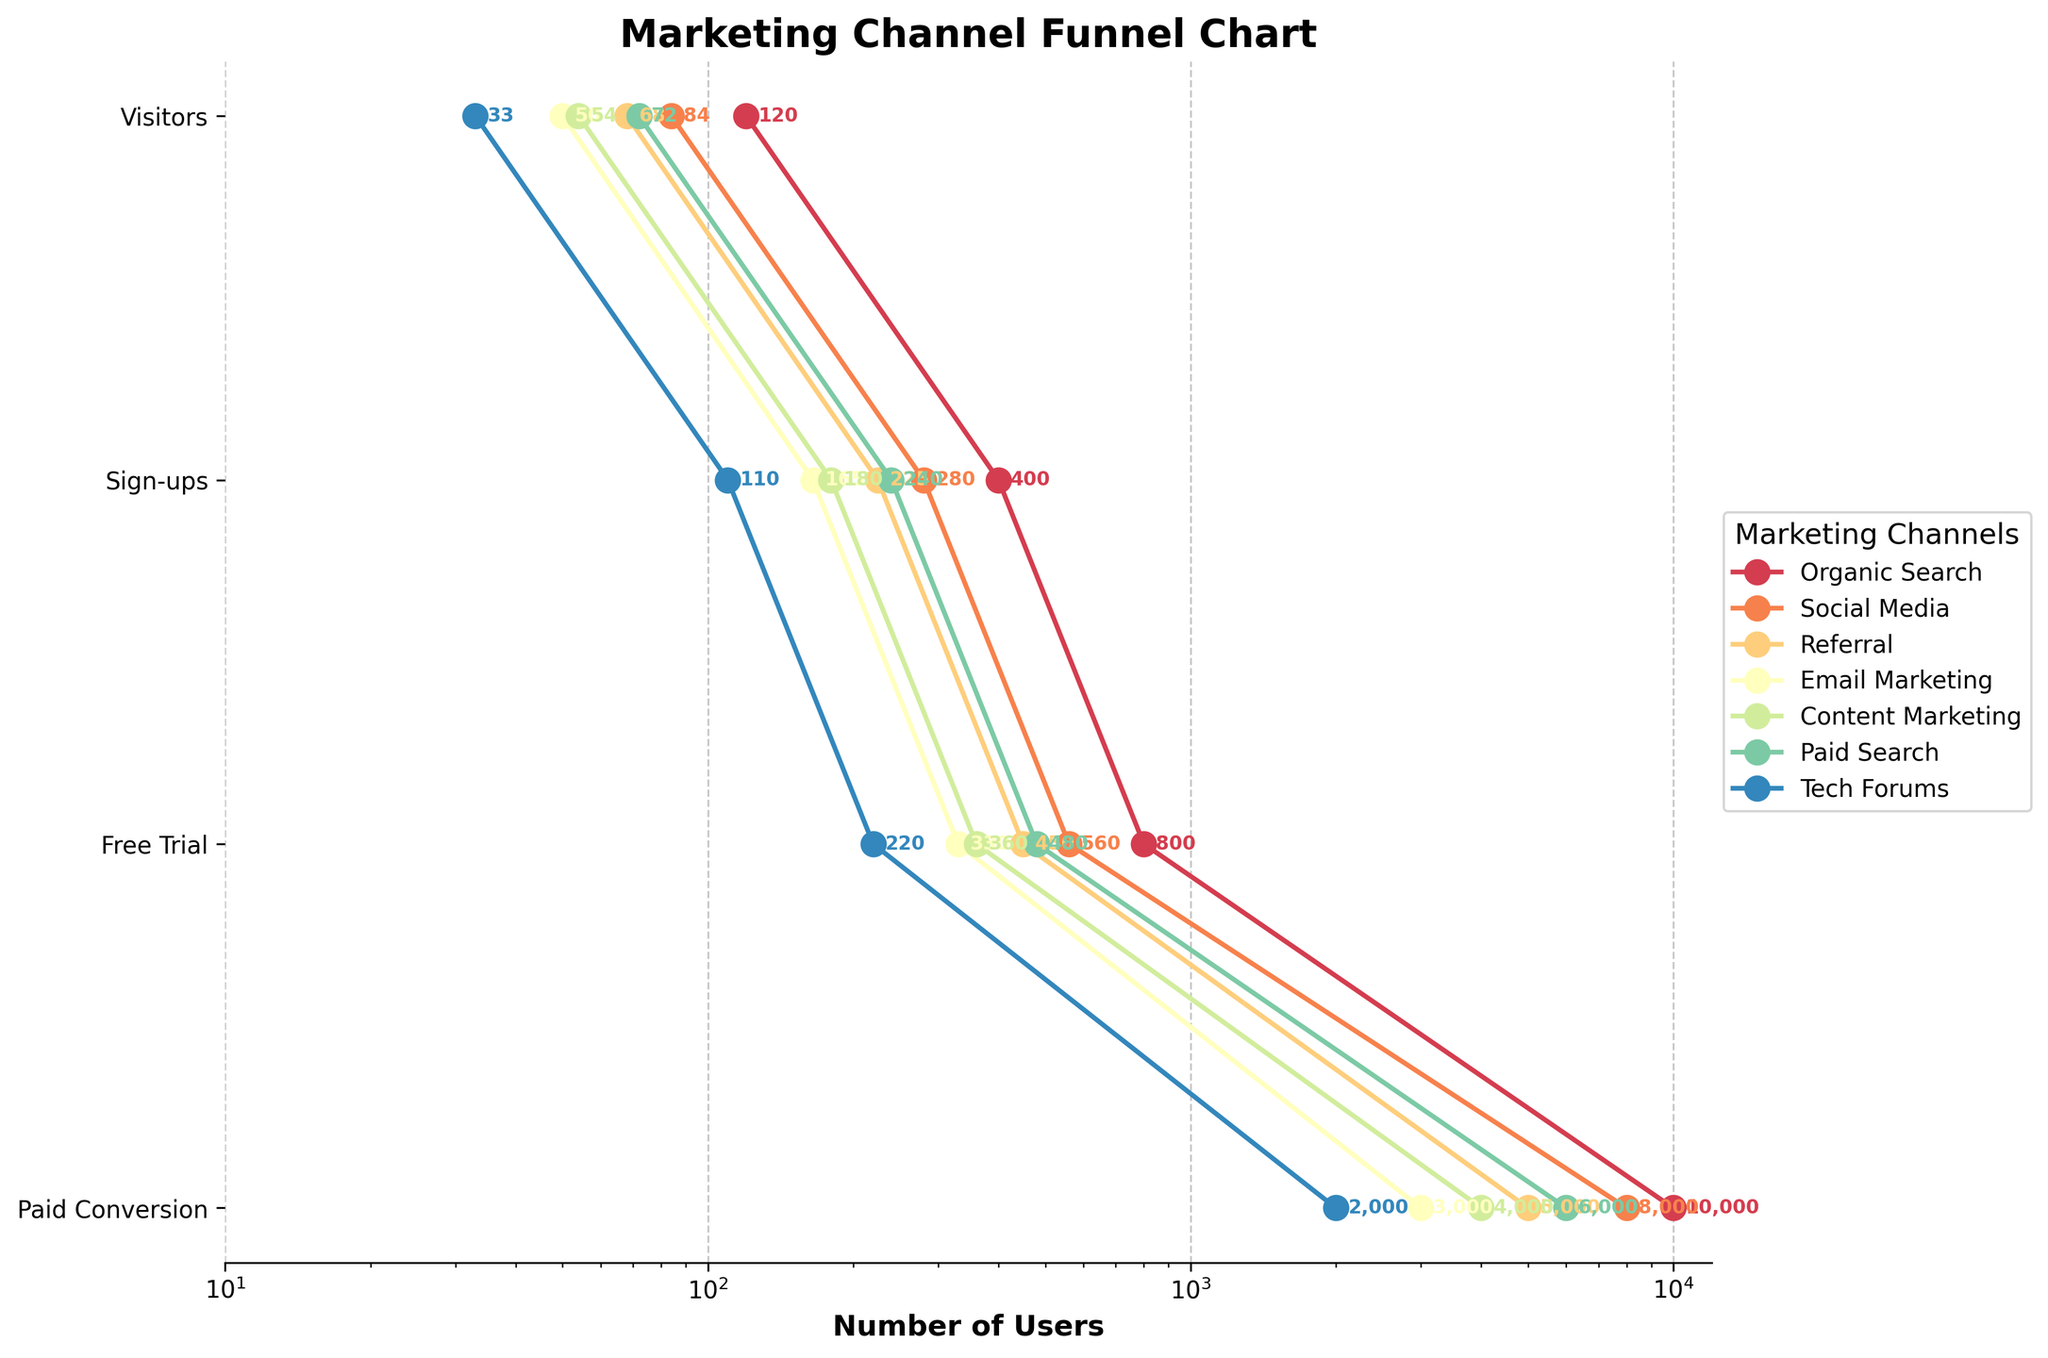What is the title of the chart? The title of the chart is usually displayed at the top of the figure and represents the main topic or caption of the visualized data.
Answer: Marketing Channel Funnel Chart Which marketing channel has the highest number of Visitors? The highest number of Visitors is represented by the longest horizontal bar in the first stage (Visitors) of the funnel chart.
Answer: Organic Search How does the number of Paid Conversions compare between Email Marketing and Tech Forums? To compare, we look at the Paid Conversions stage and compare the values for Email Marketing and Tech Forums, which are 50 and 33 respectively.
Answer: Email Marketing has more Paid Conversions What is the total number of Visitors from Social Media, Referral, and Email Marketing combined? Sum the number of Visitors from each channel: Social Media (8000) + Referral (5000) + Email Marketing (3000) = 16000.
Answer: 16000 Which stage of the funnel sees the greatest drop in the number of users across all channels? To determine this, observe the differences in numbers between stages. The drop from Visitors to Sign-ups is typically the largest.
Answer: Visitors to Sign-ups How does the number of Sign-ups for Paid Search compare to Tech Forums? Compare the number of Sign-ups directly for Paid Search (480) and Tech Forums (220) based on their positions on the chart.
Answer: Paid Search has more Sign-ups What are the colors used to distinguish different marketing channels in the chart? Colors are used to differentiate the lines and markers for each channel. Look at the chart legend to identify each color and its corresponding channel.
Answer: Varied colors (according to the colormap used, e.g., shades from the Spectral colormap) What is the average number of Paid Conversions across all marketing channels? Calculate the average by summing all Paid Conversions and dividing by the number of channels: (120 + 84 + 68 + 50 + 54 + 72 + 33) / 7 ≈ 68.71.
Answer: ~68.71 Between Organic Search and Content Marketing, which has a higher conversion rate from Free Trial to Paid Conversion? Calculate the rate for each channel. Organic Search: 120/400 = 0.3 (30%). Content Marketing: 54/180 = 0.3 (30%).
Answer: Both have the same conversion rate (30%) What is the difference in the number of Free Trials between Referral and Tech Forums? Subtract the number of Free Trials for Tech Forums from Referral: 225 - 110 = 115.
Answer: 115 